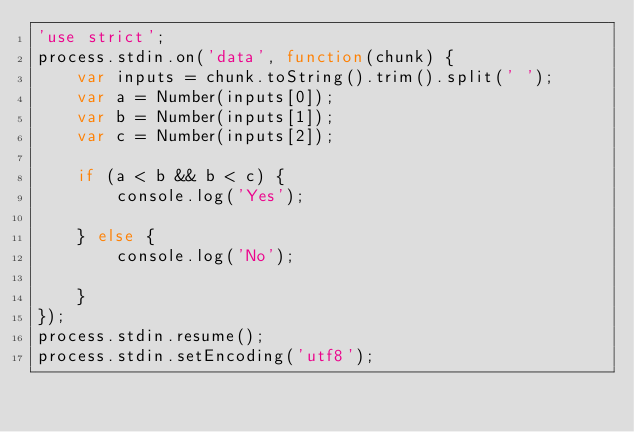Convert code to text. <code><loc_0><loc_0><loc_500><loc_500><_JavaScript_>'use strict';
process.stdin.on('data', function(chunk) {
    var inputs = chunk.toString().trim().split(' ');
    var a = Number(inputs[0]);
    var b = Number(inputs[1]);
    var c = Number(inputs[2]);

    if (a < b && b < c) {
        console.log('Yes');

    } else {
        console.log('No');

    }
});
process.stdin.resume();
process.stdin.setEncoding('utf8');</code> 